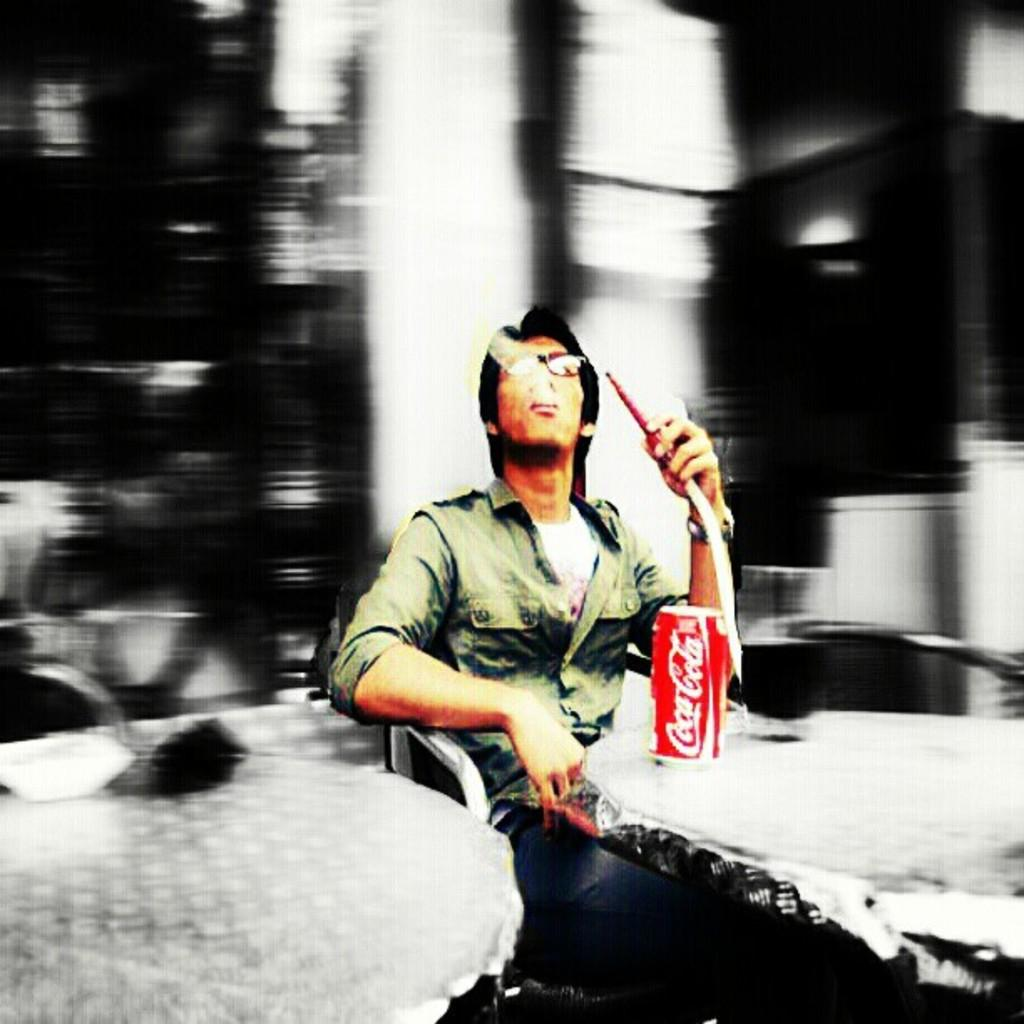What can be seen in the image? There is a person in the image. Can you describe the person's attire? The person is wearing a dress. What object is the person holding? The person is holding a pipe. What is on the table in front of the person? There is a tin on the table. What type of wax can be seen on the earth in the image? There is no wax or earth present in the image; it features a person wearing a dress, holding a pipe, and standing near a tin on a table. 